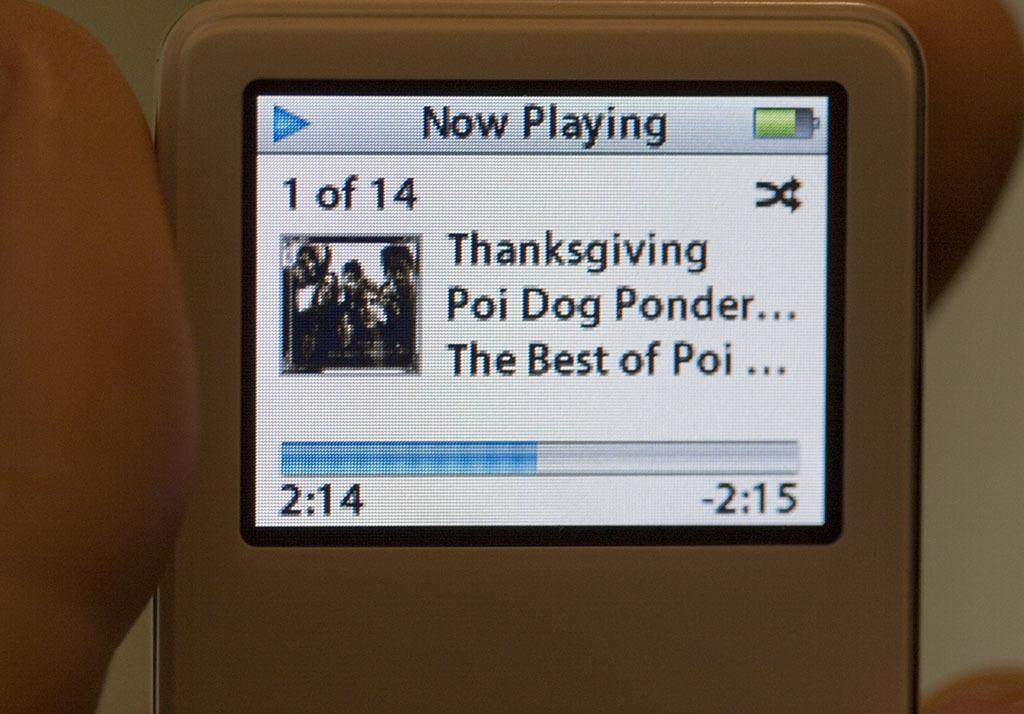How would you summarize this image in a sentence or two? In this image in the front there is an object which is white in colour and on the object there is a screen and there is some text written on the screen and there is a finger visible on the left side. 